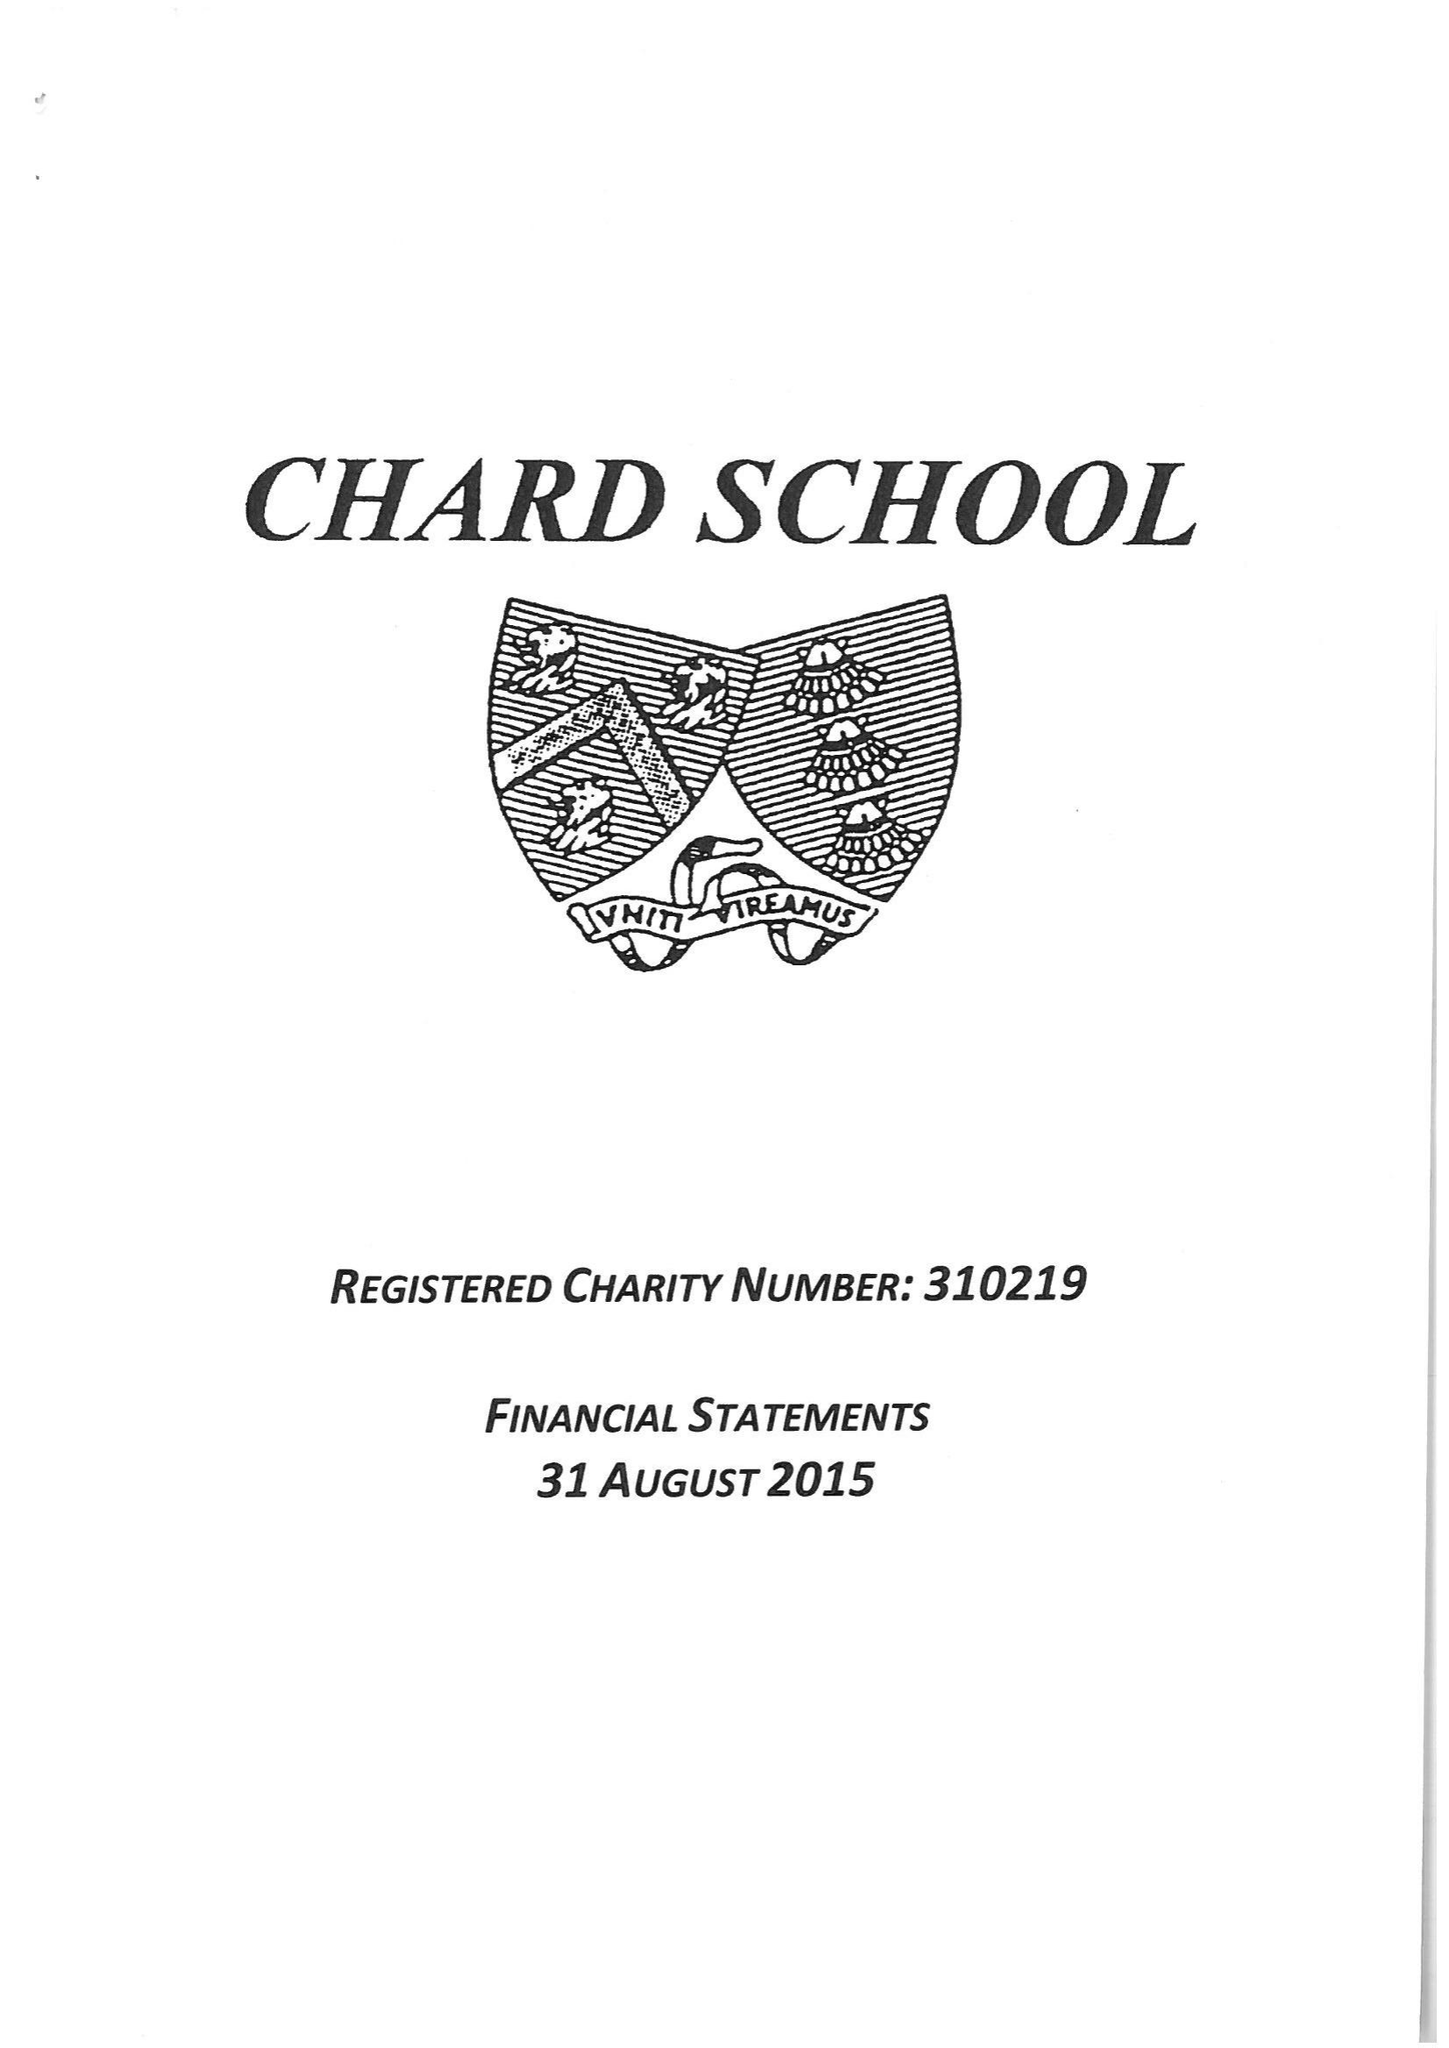What is the value for the income_annually_in_british_pounds?
Answer the question using a single word or phrase. 357139.00 